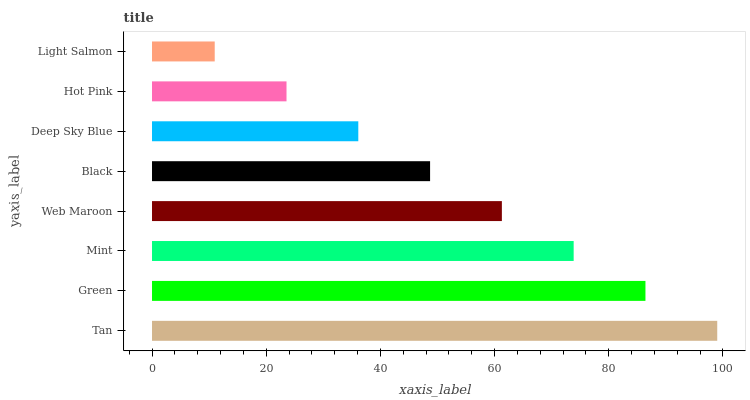Is Light Salmon the minimum?
Answer yes or no. Yes. Is Tan the maximum?
Answer yes or no. Yes. Is Green the minimum?
Answer yes or no. No. Is Green the maximum?
Answer yes or no. No. Is Tan greater than Green?
Answer yes or no. Yes. Is Green less than Tan?
Answer yes or no. Yes. Is Green greater than Tan?
Answer yes or no. No. Is Tan less than Green?
Answer yes or no. No. Is Web Maroon the high median?
Answer yes or no. Yes. Is Black the low median?
Answer yes or no. Yes. Is Black the high median?
Answer yes or no. No. Is Tan the low median?
Answer yes or no. No. 